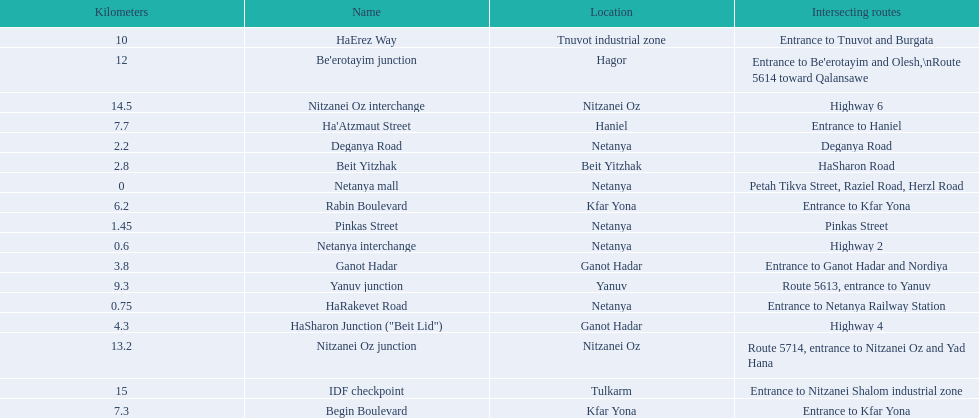Would you mind parsing the complete table? {'header': ['Kilometers', 'Name', 'Location', 'Intersecting routes'], 'rows': [['10', 'HaErez Way', 'Tnuvot industrial zone', 'Entrance to Tnuvot and Burgata'], ['12', "Be'erotayim junction", 'Hagor', "Entrance to Be'erotayim and Olesh,\\nRoute 5614 toward Qalansawe"], ['14.5', 'Nitzanei Oz interchange', 'Nitzanei Oz', 'Highway 6'], ['7.7', "Ha'Atzmaut Street", 'Haniel', 'Entrance to Haniel'], ['2.2', 'Deganya Road', 'Netanya', 'Deganya Road'], ['2.8', 'Beit Yitzhak', 'Beit Yitzhak', 'HaSharon Road'], ['0', 'Netanya mall', 'Netanya', 'Petah Tikva Street, Raziel Road, Herzl Road'], ['6.2', 'Rabin Boulevard', 'Kfar Yona', 'Entrance to Kfar Yona'], ['1.45', 'Pinkas Street', 'Netanya', 'Pinkas Street'], ['0.6', 'Netanya interchange', 'Netanya', 'Highway 2'], ['3.8', 'Ganot Hadar', 'Ganot Hadar', 'Entrance to Ganot Hadar and Nordiya'], ['9.3', 'Yanuv junction', 'Yanuv', 'Route 5613, entrance to Yanuv'], ['0.75', 'HaRakevet Road', 'Netanya', 'Entrance to Netanya Railway Station'], ['4.3', 'HaSharon Junction ("Beit Lid")', 'Ganot Hadar', 'Highway 4'], ['13.2', 'Nitzanei Oz junction', 'Nitzanei Oz', 'Route 5714, entrance to Nitzanei Oz and Yad Hana'], ['15', 'IDF checkpoint', 'Tulkarm', 'Entrance to Nitzanei Shalom industrial zone'], ['7.3', 'Begin Boulevard', 'Kfar Yona', 'Entrance to Kfar Yona']]} Which area can be found subsequent to kfar yona? Haniel. 